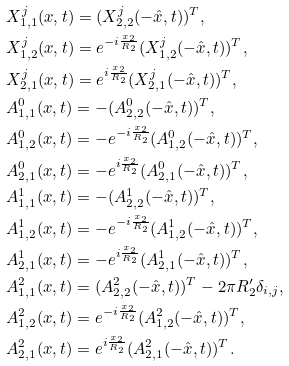<formula> <loc_0><loc_0><loc_500><loc_500>& X ^ { j } _ { 1 , 1 } ( x , t ) = ( X ^ { j } _ { 2 , 2 } ( - \hat { x } , t ) ) ^ { T } , \\ & X ^ { j } _ { 1 , 2 } ( x , t ) = e ^ { - i \frac { x _ { 2 } } { R _ { 2 } } } ( X ^ { j } _ { 1 , 2 } ( - \hat { x } , t ) ) ^ { T } , \\ & X ^ { j } _ { 2 , 1 } ( x , t ) = e ^ { i \frac { x _ { 2 } } { R _ { 2 } } } ( X ^ { j } _ { 2 , 1 } ( - \hat { x } , t ) ) ^ { T } , \\ & A ^ { 0 } _ { 1 , 1 } ( x , t ) = - ( A ^ { 0 } _ { 2 , 2 } ( - \hat { x } , t ) ) ^ { T } , \\ & A ^ { 0 } _ { 1 , 2 } ( x , t ) = - e ^ { - i \frac { x _ { 2 } } { R _ { 2 } } } ( A ^ { 0 } _ { 1 , 2 } ( - \hat { x } , t ) ) ^ { T } , \\ & A ^ { 0 } _ { 2 , 1 } ( x , t ) = - e ^ { i \frac { x _ { 2 } } { R _ { 2 } } } ( A ^ { 0 } _ { 2 , 1 } ( - \hat { x } , t ) ) ^ { T } , \\ & A ^ { 1 } _ { 1 , 1 } ( x , t ) = - ( A ^ { 1 } _ { 2 , 2 } ( - \hat { x } , t ) ) ^ { T } , \\ & A ^ { 1 } _ { 1 , 2 } ( x , t ) = - e ^ { - i \frac { x _ { 2 } } { R _ { 2 } } } ( A ^ { 1 } _ { 1 , 2 } ( - \hat { x } , t ) ) ^ { T } , \\ & A ^ { 1 } _ { 2 , 1 } ( x , t ) = - e ^ { i \frac { x _ { 2 } } { R _ { 2 } } } ( A ^ { 1 } _ { 2 , 1 } ( - \hat { x } , t ) ) ^ { T } , \\ & A ^ { 2 } _ { 1 , 1 } ( x , t ) = ( A ^ { 2 } _ { 2 , 2 } ( - \hat { x } , t ) ) ^ { T } - 2 \pi R ^ { \prime } _ { 2 } \delta _ { i , j } , \\ & A ^ { 2 } _ { 1 , 2 } ( x , t ) = e ^ { - i \frac { x _ { 2 } } { R _ { 2 } } } ( A ^ { 2 } _ { 1 , 2 } ( - \hat { x } , t ) ) ^ { T } , \\ & A ^ { 2 } _ { 2 , 1 } ( x , t ) = e ^ { i \frac { x _ { 2 } } { R _ { 2 } } } ( A ^ { 2 } _ { 2 , 1 } ( - \hat { x } , t ) ) ^ { T } .</formula> 